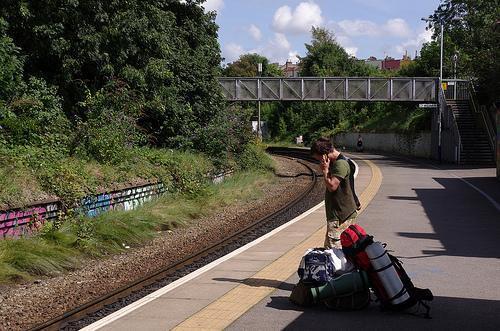How many people are shown?
Give a very brief answer. 1. 